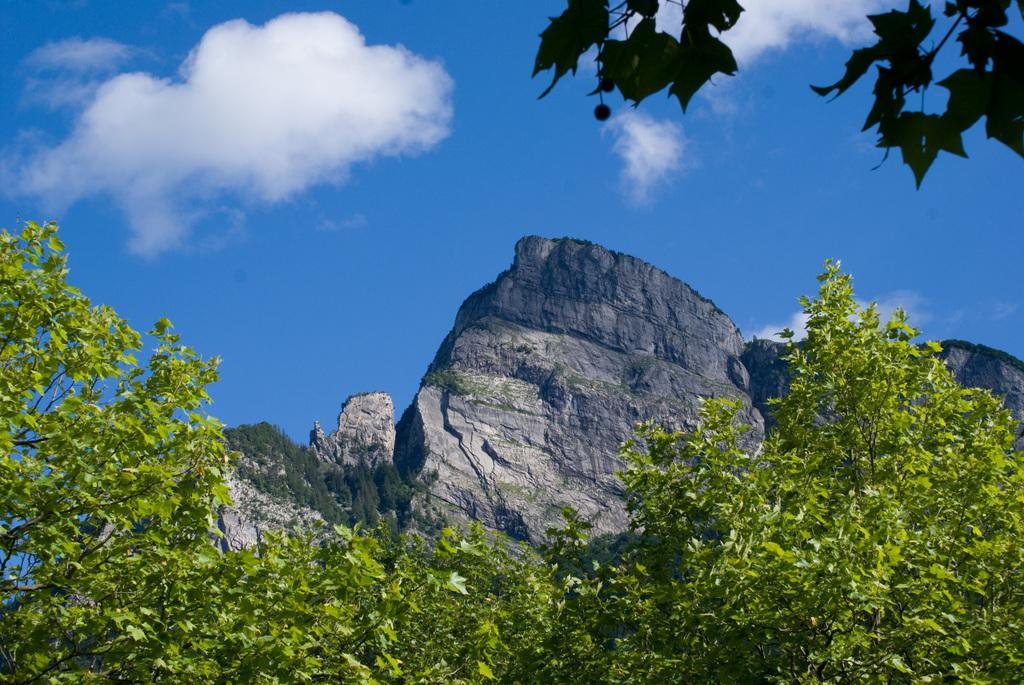What type of vegetation can be seen in the image? There are green color leaves in the image. What can be seen in the sky in the image? Clouds are visible in the image. What is the primary element of the image? The sky is present in the image. What type of table is being used in the fight scene in the image? There is no fight scene or table present in the image; it features green color leaves and clouds in the sky. 